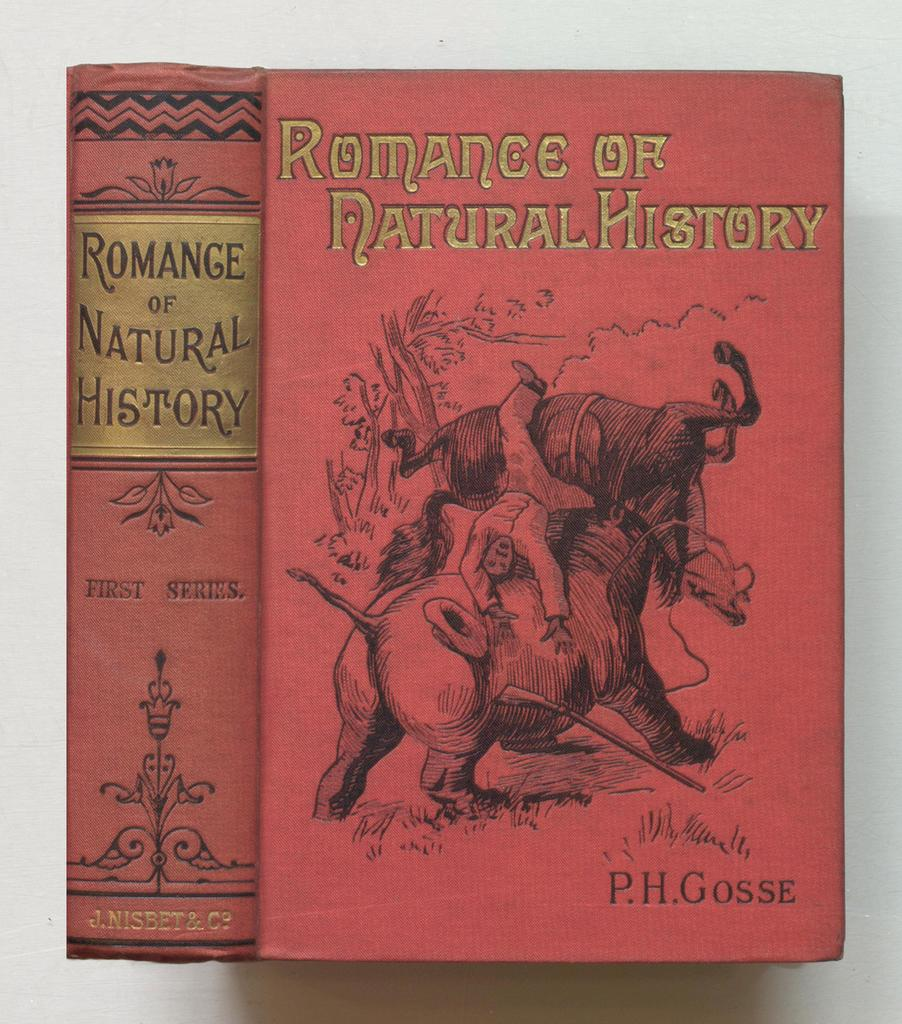<image>
Give a short and clear explanation of the subsequent image. a book titled romance of natural history is shown 